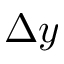Convert formula to latex. <formula><loc_0><loc_0><loc_500><loc_500>\Delta y</formula> 